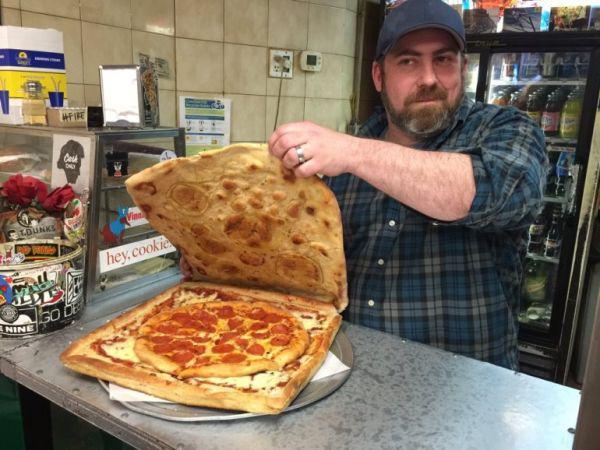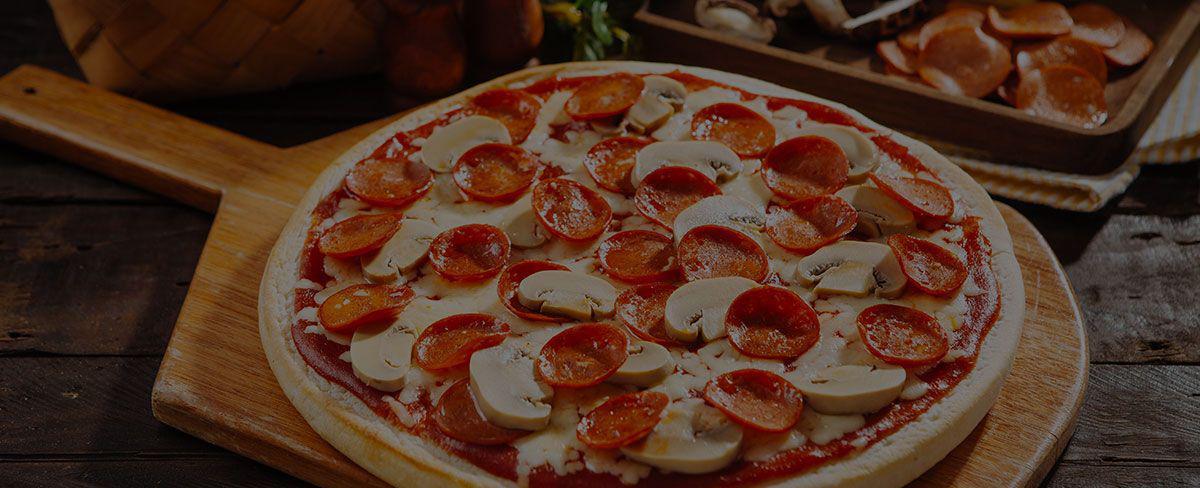The first image is the image on the left, the second image is the image on the right. Assess this claim about the two images: "All pizzas in the right image are in boxes.". Correct or not? Answer yes or no. No. The first image is the image on the left, the second image is the image on the right. Examine the images to the left and right. Is the description "The pizzas in the image on the right are still in their boxes." accurate? Answer yes or no. No. 